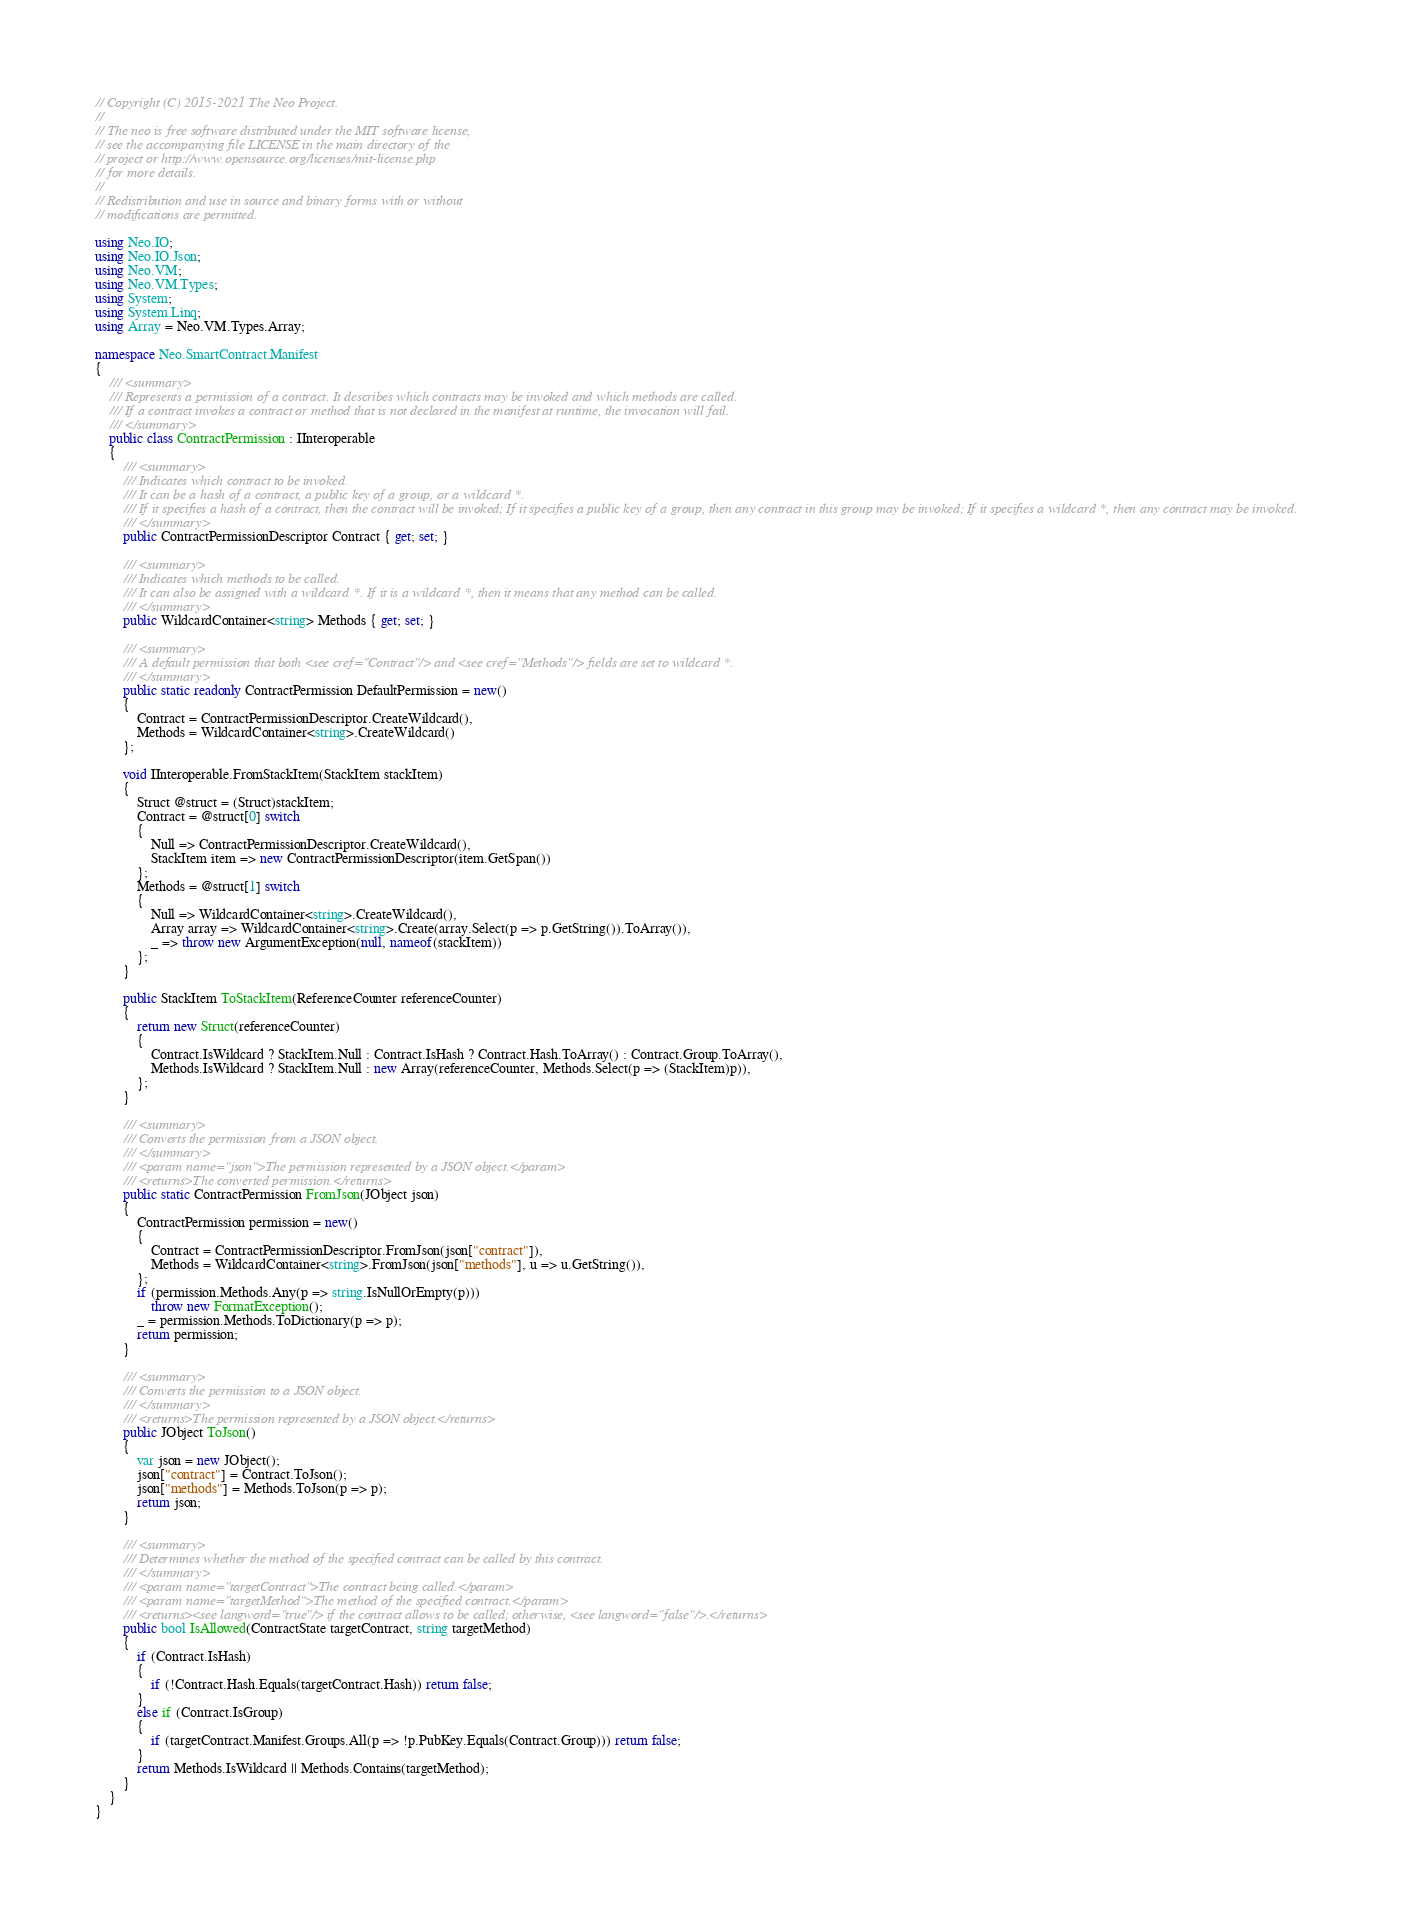<code> <loc_0><loc_0><loc_500><loc_500><_C#_>// Copyright (C) 2015-2021 The Neo Project.
// 
// The neo is free software distributed under the MIT software license, 
// see the accompanying file LICENSE in the main directory of the
// project or http://www.opensource.org/licenses/mit-license.php 
// for more details.
// 
// Redistribution and use in source and binary forms with or without
// modifications are permitted.

using Neo.IO;
using Neo.IO.Json;
using Neo.VM;
using Neo.VM.Types;
using System;
using System.Linq;
using Array = Neo.VM.Types.Array;

namespace Neo.SmartContract.Manifest
{
    /// <summary>
    /// Represents a permission of a contract. It describes which contracts may be invoked and which methods are called.
    /// If a contract invokes a contract or method that is not declared in the manifest at runtime, the invocation will fail.
    /// </summary>
    public class ContractPermission : IInteroperable
    {
        /// <summary>
        /// Indicates which contract to be invoked.
        /// It can be a hash of a contract, a public key of a group, or a wildcard *.
        /// If it specifies a hash of a contract, then the contract will be invoked; If it specifies a public key of a group, then any contract in this group may be invoked; If it specifies a wildcard *, then any contract may be invoked.
        /// </summary>
        public ContractPermissionDescriptor Contract { get; set; }

        /// <summary>
        /// Indicates which methods to be called.
        /// It can also be assigned with a wildcard *. If it is a wildcard *, then it means that any method can be called.
        /// </summary>
        public WildcardContainer<string> Methods { get; set; }

        /// <summary>
        /// A default permission that both <see cref="Contract"/> and <see cref="Methods"/> fields are set to wildcard *.
        /// </summary>
        public static readonly ContractPermission DefaultPermission = new()
        {
            Contract = ContractPermissionDescriptor.CreateWildcard(),
            Methods = WildcardContainer<string>.CreateWildcard()
        };

        void IInteroperable.FromStackItem(StackItem stackItem)
        {
            Struct @struct = (Struct)stackItem;
            Contract = @struct[0] switch
            {
                Null => ContractPermissionDescriptor.CreateWildcard(),
                StackItem item => new ContractPermissionDescriptor(item.GetSpan())
            };
            Methods = @struct[1] switch
            {
                Null => WildcardContainer<string>.CreateWildcard(),
                Array array => WildcardContainer<string>.Create(array.Select(p => p.GetString()).ToArray()),
                _ => throw new ArgumentException(null, nameof(stackItem))
            };
        }

        public StackItem ToStackItem(ReferenceCounter referenceCounter)
        {
            return new Struct(referenceCounter)
            {
                Contract.IsWildcard ? StackItem.Null : Contract.IsHash ? Contract.Hash.ToArray() : Contract.Group.ToArray(),
                Methods.IsWildcard ? StackItem.Null : new Array(referenceCounter, Methods.Select(p => (StackItem)p)),
            };
        }

        /// <summary>
        /// Converts the permission from a JSON object.
        /// </summary>
        /// <param name="json">The permission represented by a JSON object.</param>
        /// <returns>The converted permission.</returns>
        public static ContractPermission FromJson(JObject json)
        {
            ContractPermission permission = new()
            {
                Contract = ContractPermissionDescriptor.FromJson(json["contract"]),
                Methods = WildcardContainer<string>.FromJson(json["methods"], u => u.GetString()),
            };
            if (permission.Methods.Any(p => string.IsNullOrEmpty(p)))
                throw new FormatException();
            _ = permission.Methods.ToDictionary(p => p);
            return permission;
        }

        /// <summary>
        /// Converts the permission to a JSON object.
        /// </summary>
        /// <returns>The permission represented by a JSON object.</returns>
        public JObject ToJson()
        {
            var json = new JObject();
            json["contract"] = Contract.ToJson();
            json["methods"] = Methods.ToJson(p => p);
            return json;
        }

        /// <summary>
        /// Determines whether the method of the specified contract can be called by this contract.
        /// </summary>
        /// <param name="targetContract">The contract being called.</param>
        /// <param name="targetMethod">The method of the specified contract.</param>
        /// <returns><see langword="true"/> if the contract allows to be called; otherwise, <see langword="false"/>.</returns>
        public bool IsAllowed(ContractState targetContract, string targetMethod)
        {
            if (Contract.IsHash)
            {
                if (!Contract.Hash.Equals(targetContract.Hash)) return false;
            }
            else if (Contract.IsGroup)
            {
                if (targetContract.Manifest.Groups.All(p => !p.PubKey.Equals(Contract.Group))) return false;
            }
            return Methods.IsWildcard || Methods.Contains(targetMethod);
        }
    }
}
</code> 